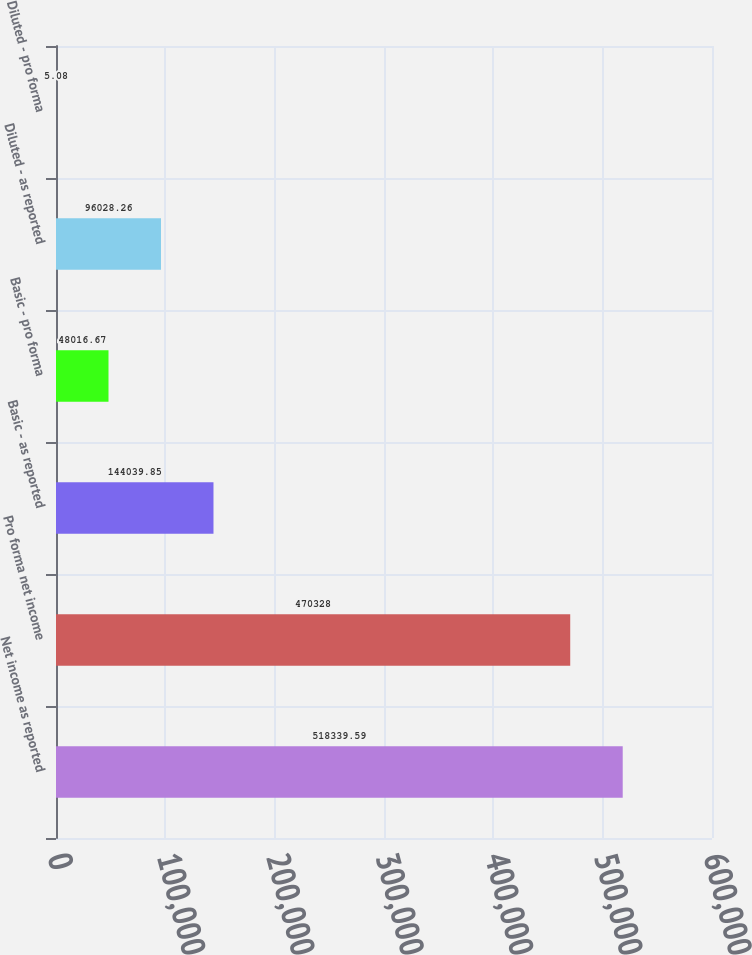Convert chart to OTSL. <chart><loc_0><loc_0><loc_500><loc_500><bar_chart><fcel>Net income as reported<fcel>Pro forma net income<fcel>Basic - as reported<fcel>Basic - pro forma<fcel>Diluted - as reported<fcel>Diluted - pro forma<nl><fcel>518340<fcel>470328<fcel>144040<fcel>48016.7<fcel>96028.3<fcel>5.08<nl></chart> 